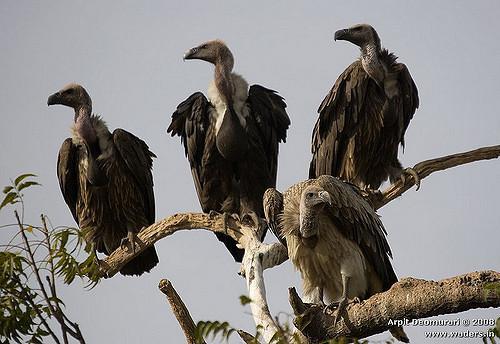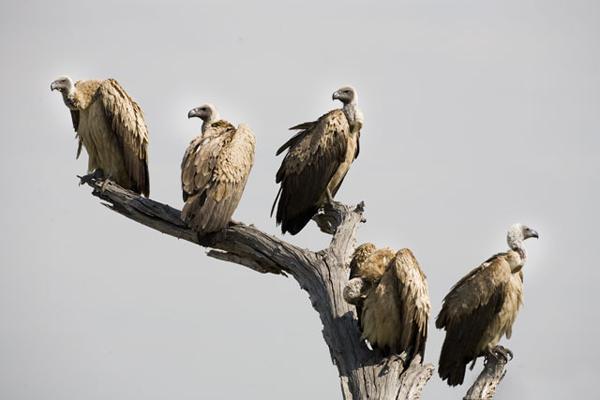The first image is the image on the left, the second image is the image on the right. Assess this claim about the two images: "At least one of the images contains exactly one bird.". Correct or not? Answer yes or no. No. The first image is the image on the left, the second image is the image on the right. Considering the images on both sides, is "there is exactly one bird in the image on the left" valid? Answer yes or no. No. 